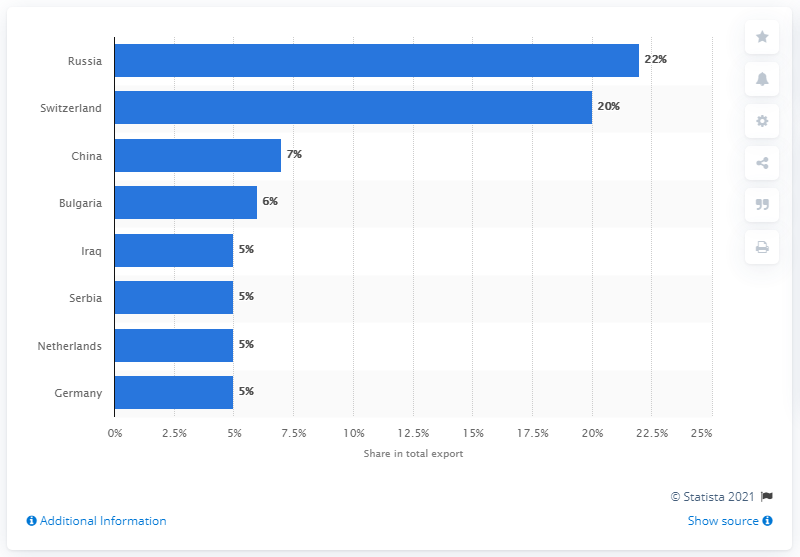Outline some significant characteristics in this image. In 2019, Russia was Armenia's most important export partner, accounting for a significant portion of the country's total exports. 